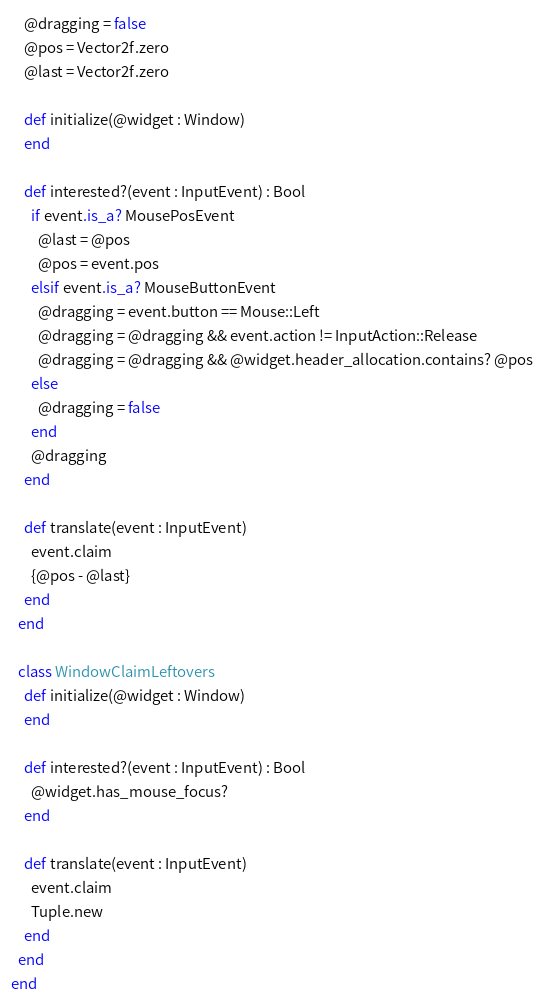Convert code to text. <code><loc_0><loc_0><loc_500><loc_500><_Crystal_>    @dragging = false
    @pos = Vector2f.zero
    @last = Vector2f.zero

    def initialize(@widget : Window)
    end

    def interested?(event : InputEvent) : Bool
      if event.is_a? MousePosEvent
        @last = @pos
        @pos = event.pos
      elsif event.is_a? MouseButtonEvent
        @dragging = event.button == Mouse::Left
        @dragging = @dragging && event.action != InputAction::Release
        @dragging = @dragging && @widget.header_allocation.contains? @pos
      else
        @dragging = false
      end
      @dragging
    end

    def translate(event : InputEvent)
      event.claim
      {@pos - @last}
    end
  end

  class WindowClaimLeftovers
    def initialize(@widget : Window)
    end

    def interested?(event : InputEvent) : Bool
      @widget.has_mouse_focus?
    end

    def translate(event : InputEvent)
      event.claim
      Tuple.new
    end
  end
end</code> 